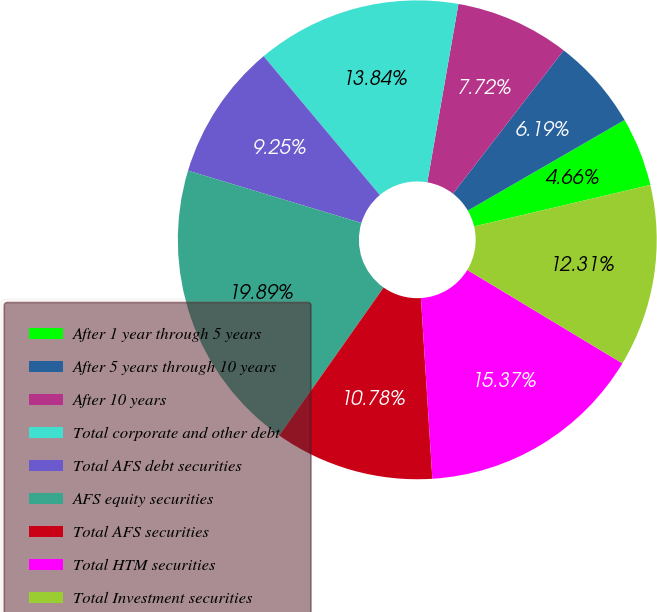Convert chart to OTSL. <chart><loc_0><loc_0><loc_500><loc_500><pie_chart><fcel>After 1 year through 5 years<fcel>After 5 years through 10 years<fcel>After 10 years<fcel>Total corporate and other debt<fcel>Total AFS debt securities<fcel>AFS equity securities<fcel>Total AFS securities<fcel>Total HTM securities<fcel>Total Investment securities<nl><fcel>4.66%<fcel>6.19%<fcel>7.72%<fcel>13.84%<fcel>9.25%<fcel>19.89%<fcel>10.78%<fcel>15.37%<fcel>12.31%<nl></chart> 